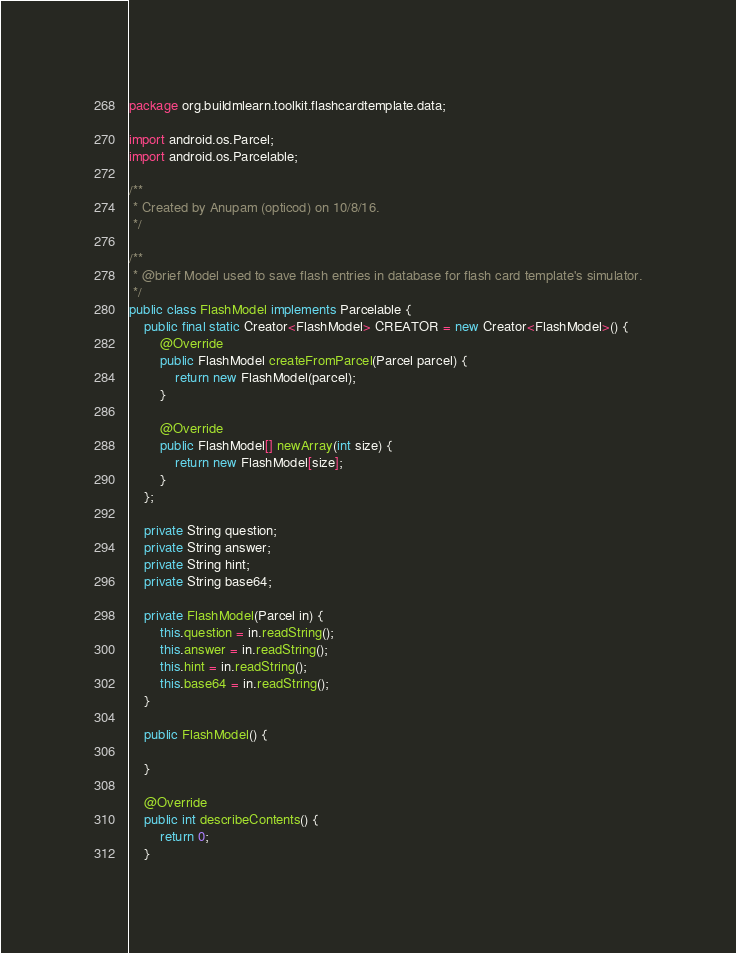<code> <loc_0><loc_0><loc_500><loc_500><_Java_>package org.buildmlearn.toolkit.flashcardtemplate.data;

import android.os.Parcel;
import android.os.Parcelable;

/**
 * Created by Anupam (opticod) on 10/8/16.
 */

/**
 * @brief Model used to save flash entries in database for flash card template's simulator.
 */
public class FlashModel implements Parcelable {
    public final static Creator<FlashModel> CREATOR = new Creator<FlashModel>() {
        @Override
        public FlashModel createFromParcel(Parcel parcel) {
            return new FlashModel(parcel);
        }

        @Override
        public FlashModel[] newArray(int size) {
            return new FlashModel[size];
        }
    };

    private String question;
    private String answer;
    private String hint;
    private String base64;

    private FlashModel(Parcel in) {
        this.question = in.readString();
        this.answer = in.readString();
        this.hint = in.readString();
        this.base64 = in.readString();
    }

    public FlashModel() {

    }

    @Override
    public int describeContents() {
        return 0;
    }
</code> 